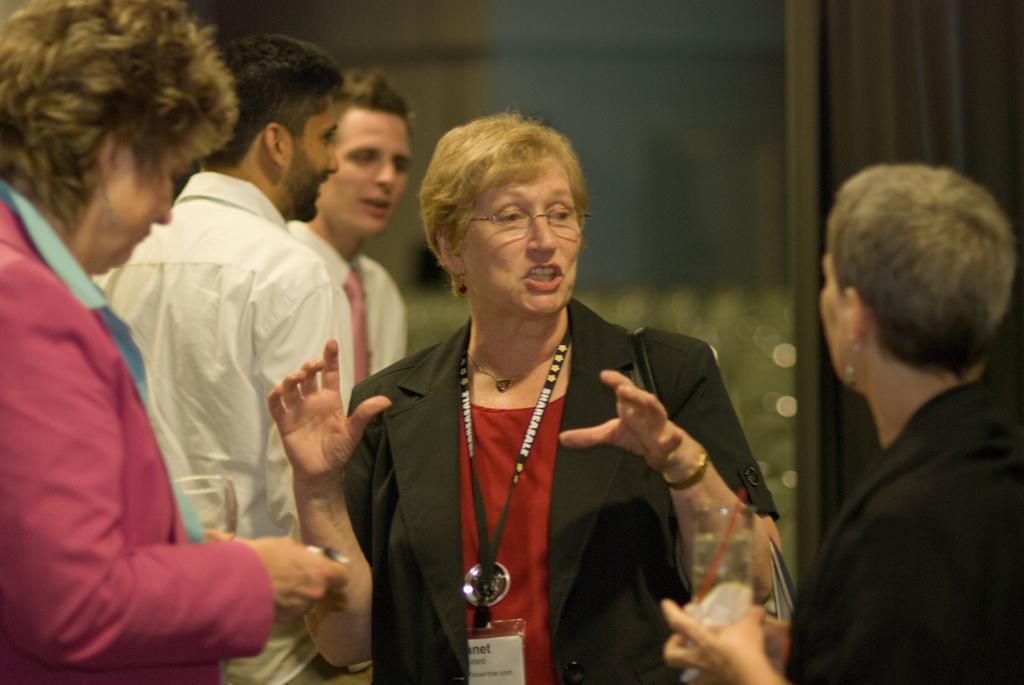In one or two sentences, can you explain what this image depicts? In this image there is a woman with black suit is talking to the other woman who is holding a glass of drink. In the left there is a woman wearing pink suit and behind the women there are two men with white shirts. The background is blurry. 